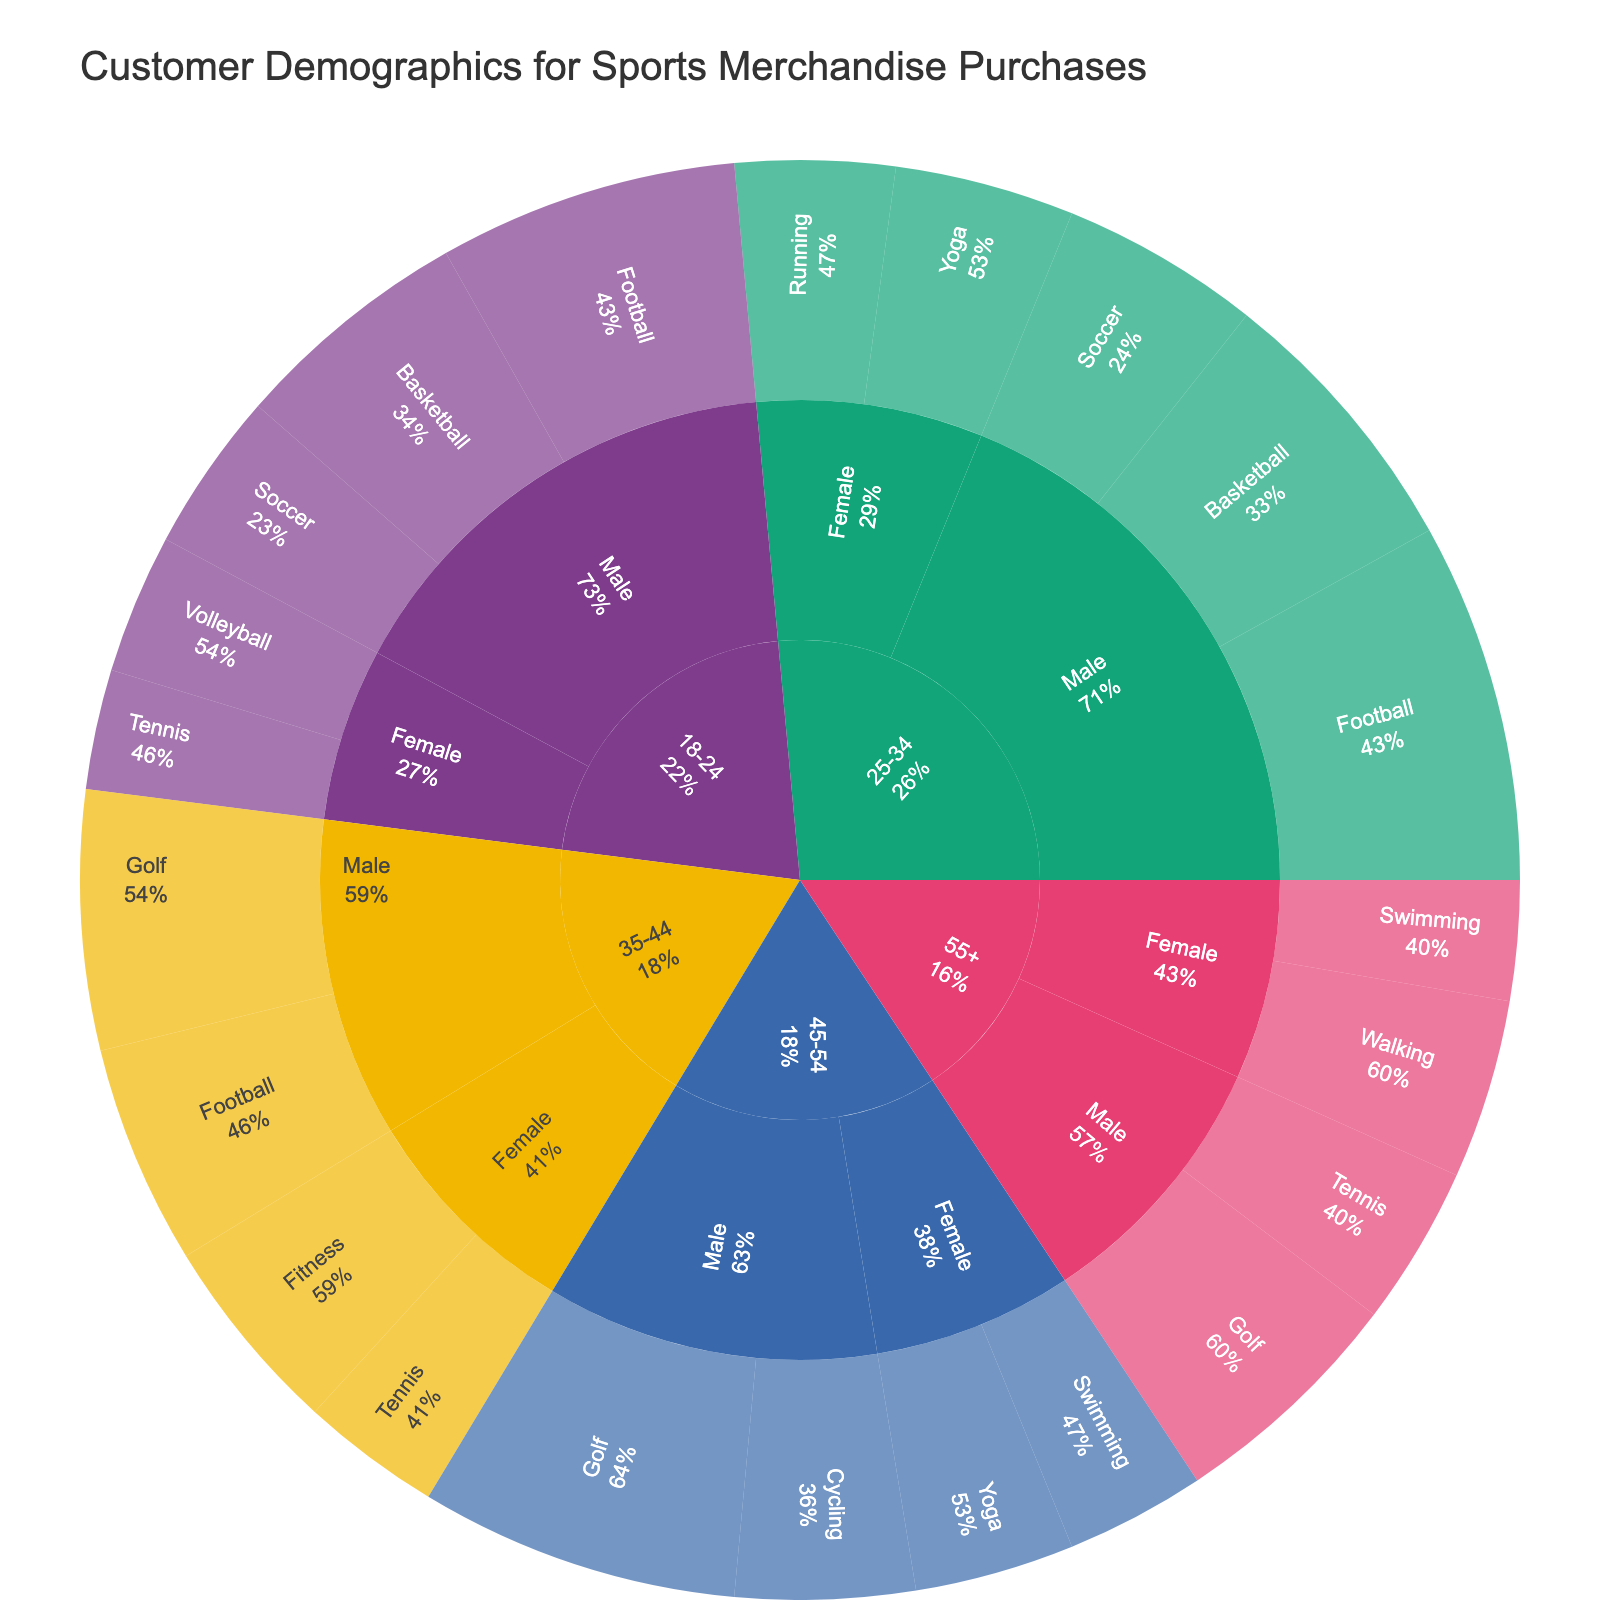What is the most preferred sport for males aged 18-24? Look for the slice under "18-24" age, then navigate to "Male" group, and identify the sport with the highest percentage in this subgroup.
Answer: Football Which gender shows a higher preference for Golf? Identify both the "Male" and "Female" slices and find the percentages associated with Golf within each gender. Compare these percentages.
Answer: Male What is the total percentage of females aged 25-34 who prefer either Yoga or Running? Sum the percentages for "Yoga" and "Running" under "25-34" age and "Female" group.
Answer: 17 Which age group contributes the highest percentage to the Football category? Navigate through the "Football" slices in each age group and compare their percentages to find the highest one.
Answer: 25-34 What proportion of purchases does the 35-44 age group account for, looking only at the Fitness category among females? Find the segment for "35-44" age and "Female" gender under "Fitness" and read its percentage.
Answer: 10 Is Tennis more popular among females aged 18-24 or 35-44? Compare the Tennis percentages in "Female" segments across "18-24" and "35-44" age groups.
Answer: 18-24 Among the 45-54 age group, what percentage of males prefer Cycling over any other sport? Locate the "45-54" age group, then the "Male" gender, and find the percentage for Cycling in comparison to the other sports.
Answer: 9 What are the two most popular sports among individuals aged 55+? Identify the segments under the "55+" age group and list the sports with the highest percentages.
Answer: Golf, Walking Which sport has the least preference among females aged 45-54? Navigate to the "45-54" age and "Female" subgroup, then identify and compare the percentages of all sports to find the smallest one.
Answer: Swimming How does the popularity of Soccer compare between males aged 18-24 and 25-34? Observe the percentages for Soccer under both the "18-24" and "25-34" male subgroups and compare them.
Answer: 18-24 < 25-34 